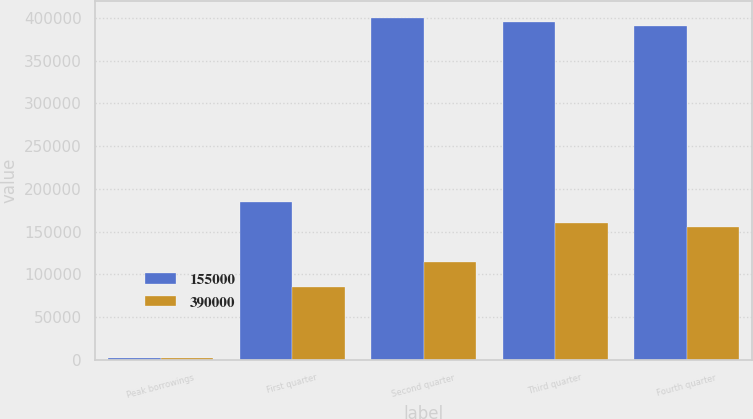Convert chart. <chart><loc_0><loc_0><loc_500><loc_500><stacked_bar_chart><ecel><fcel>Peak borrowings<fcel>First quarter<fcel>Second quarter<fcel>Third quarter<fcel>Fourth quarter<nl><fcel>155000<fcel>2015<fcel>185000<fcel>400000<fcel>395000<fcel>390000<nl><fcel>390000<fcel>2014<fcel>85000<fcel>115000<fcel>160000<fcel>155000<nl></chart> 